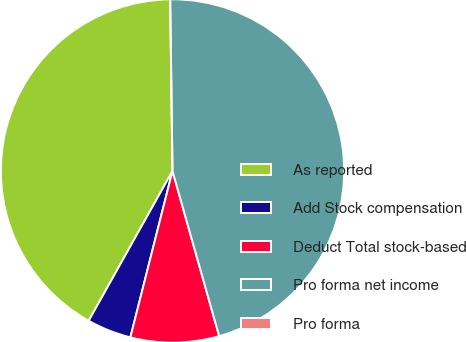<chart> <loc_0><loc_0><loc_500><loc_500><pie_chart><fcel>As reported<fcel>Add Stock compensation<fcel>Deduct Total stock-based<fcel>Pro forma net income<fcel>Pro forma<nl><fcel>41.67%<fcel>4.17%<fcel>8.33%<fcel>45.83%<fcel>0.0%<nl></chart> 